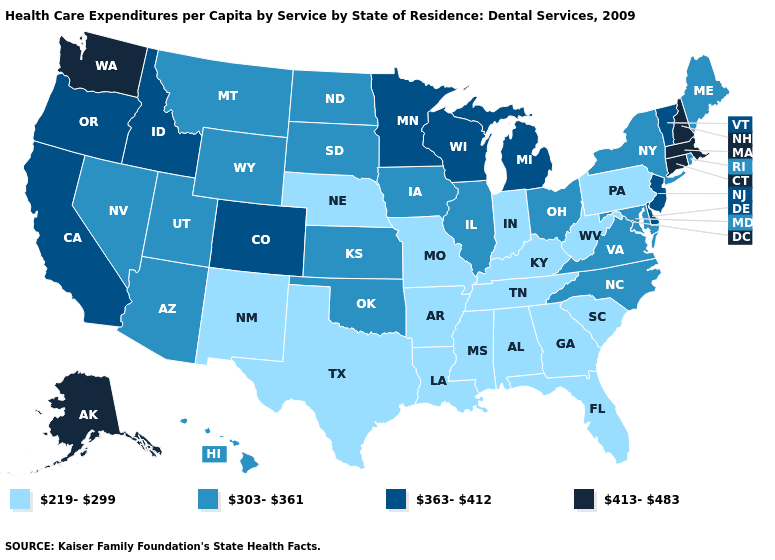Name the states that have a value in the range 413-483?
Quick response, please. Alaska, Connecticut, Massachusetts, New Hampshire, Washington. Name the states that have a value in the range 303-361?
Quick response, please. Arizona, Hawaii, Illinois, Iowa, Kansas, Maine, Maryland, Montana, Nevada, New York, North Carolina, North Dakota, Ohio, Oklahoma, Rhode Island, South Dakota, Utah, Virginia, Wyoming. What is the value of Montana?
Keep it brief. 303-361. Name the states that have a value in the range 363-412?
Short answer required. California, Colorado, Delaware, Idaho, Michigan, Minnesota, New Jersey, Oregon, Vermont, Wisconsin. What is the highest value in the USA?
Give a very brief answer. 413-483. What is the value of Maine?
Answer briefly. 303-361. Which states have the highest value in the USA?
Concise answer only. Alaska, Connecticut, Massachusetts, New Hampshire, Washington. What is the highest value in states that border Kansas?
Give a very brief answer. 363-412. How many symbols are there in the legend?
Give a very brief answer. 4. Name the states that have a value in the range 219-299?
Give a very brief answer. Alabama, Arkansas, Florida, Georgia, Indiana, Kentucky, Louisiana, Mississippi, Missouri, Nebraska, New Mexico, Pennsylvania, South Carolina, Tennessee, Texas, West Virginia. Does Illinois have a lower value than Oklahoma?
Short answer required. No. Name the states that have a value in the range 219-299?
Quick response, please. Alabama, Arkansas, Florida, Georgia, Indiana, Kentucky, Louisiana, Mississippi, Missouri, Nebraska, New Mexico, Pennsylvania, South Carolina, Tennessee, Texas, West Virginia. What is the value of California?
Be succinct. 363-412. Name the states that have a value in the range 363-412?
Write a very short answer. California, Colorado, Delaware, Idaho, Michigan, Minnesota, New Jersey, Oregon, Vermont, Wisconsin. What is the value of Arizona?
Keep it brief. 303-361. 